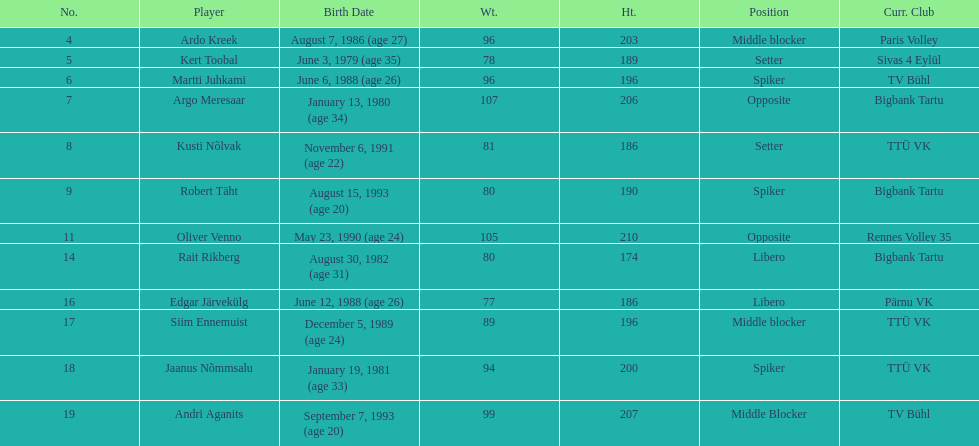How many players were born before 1988? 5. 